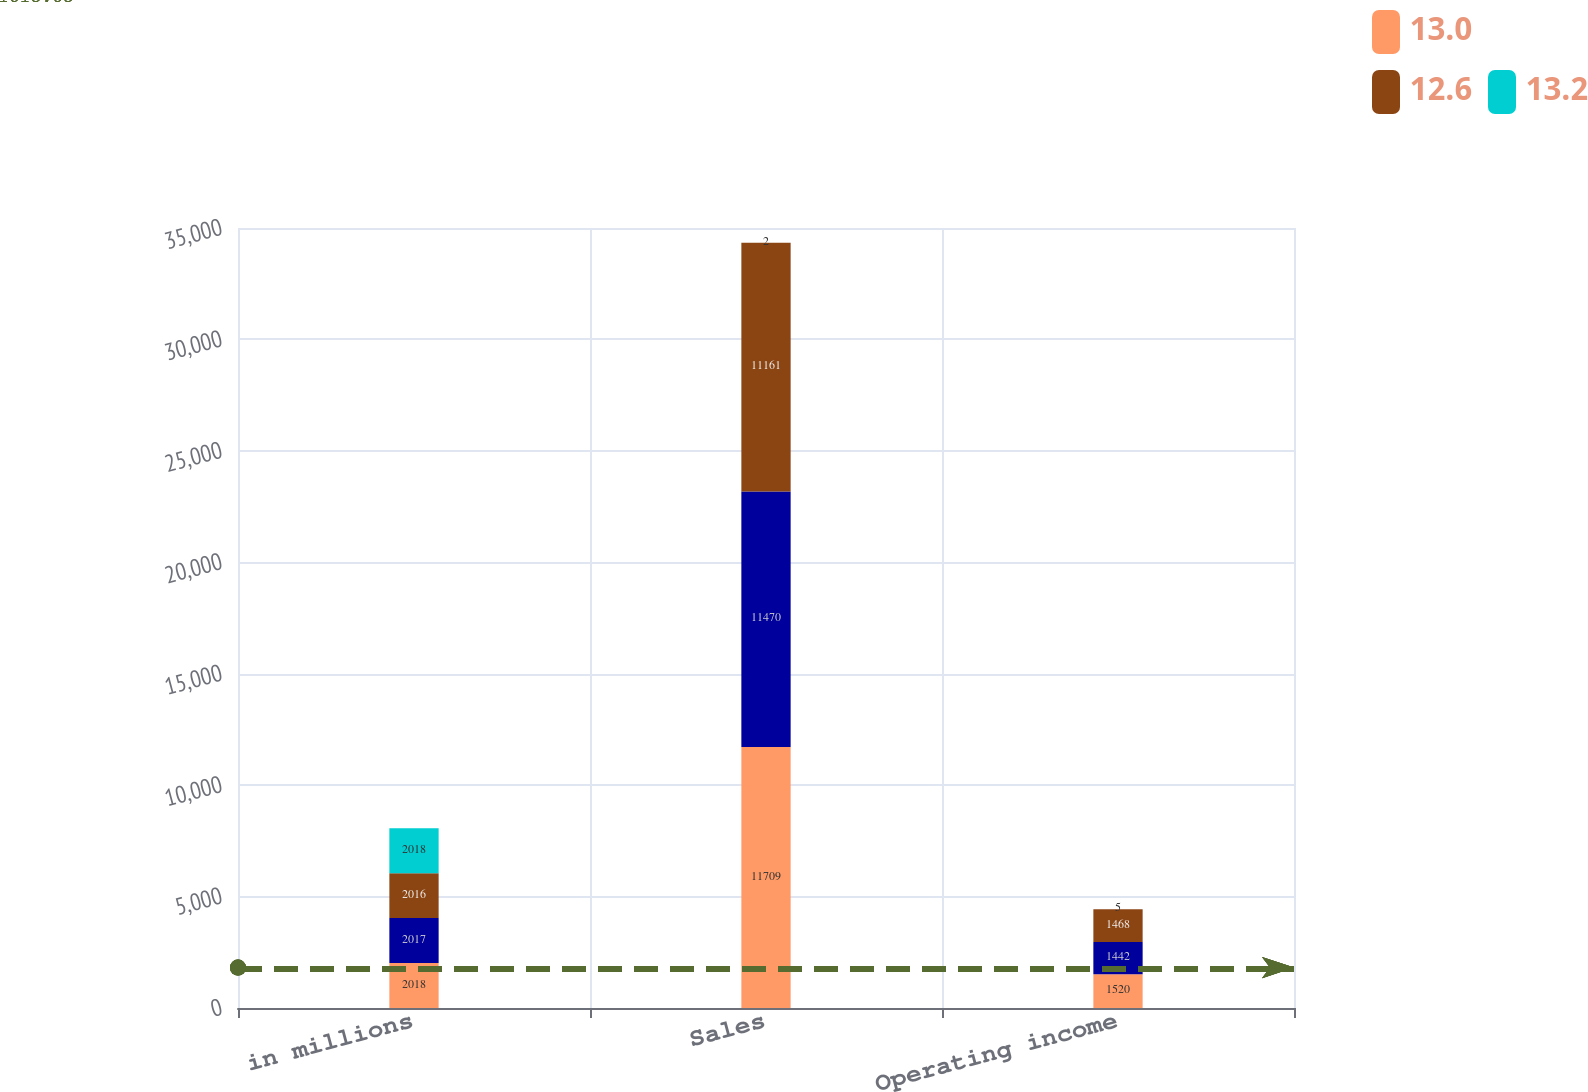<chart> <loc_0><loc_0><loc_500><loc_500><stacked_bar_chart><ecel><fcel>in millions<fcel>Sales<fcel>Operating income<nl><fcel>13<fcel>2018<fcel>11709<fcel>1520<nl><fcel>nan<fcel>2017<fcel>11470<fcel>1442<nl><fcel>12.6<fcel>2016<fcel>11161<fcel>1468<nl><fcel>13.2<fcel>2018<fcel>2<fcel>5<nl></chart> 